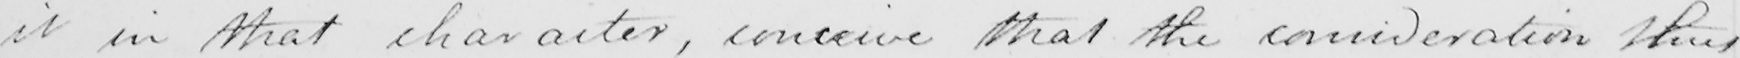Please provide the text content of this handwritten line. it in that character , conceive that the consideration thus 